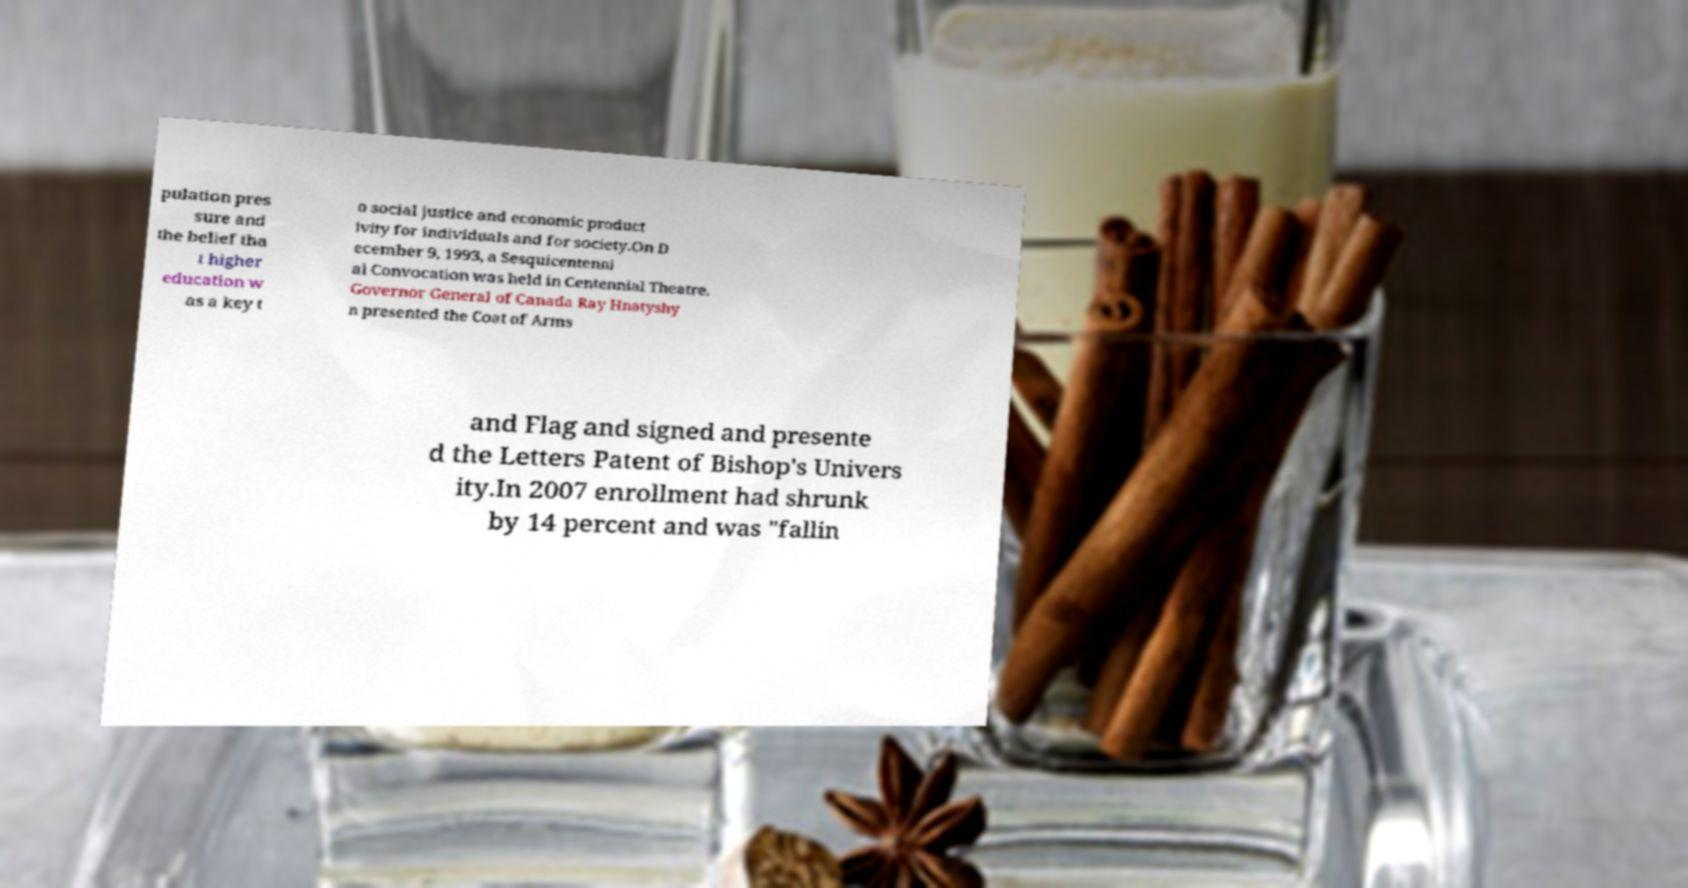Could you extract and type out the text from this image? pulation pres sure and the belief tha t higher education w as a key t o social justice and economic product ivity for individuals and for society.On D ecember 9, 1993, a Sesquicentenni al Convocation was held in Centennial Theatre. Governor General of Canada Ray Hnatyshy n presented the Coat of Arms and Flag and signed and presente d the Letters Patent of Bishop's Univers ity.In 2007 enrollment had shrunk by 14 percent and was "fallin 